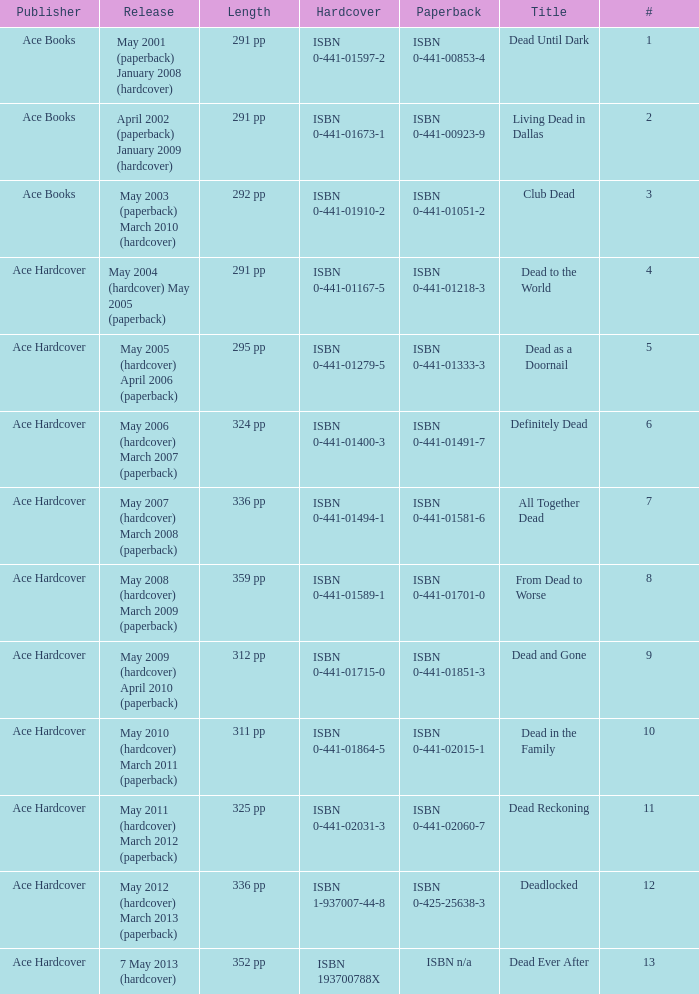What is the ISBN of "Dead as a Doornail? ISBN 0-441-01333-3. 